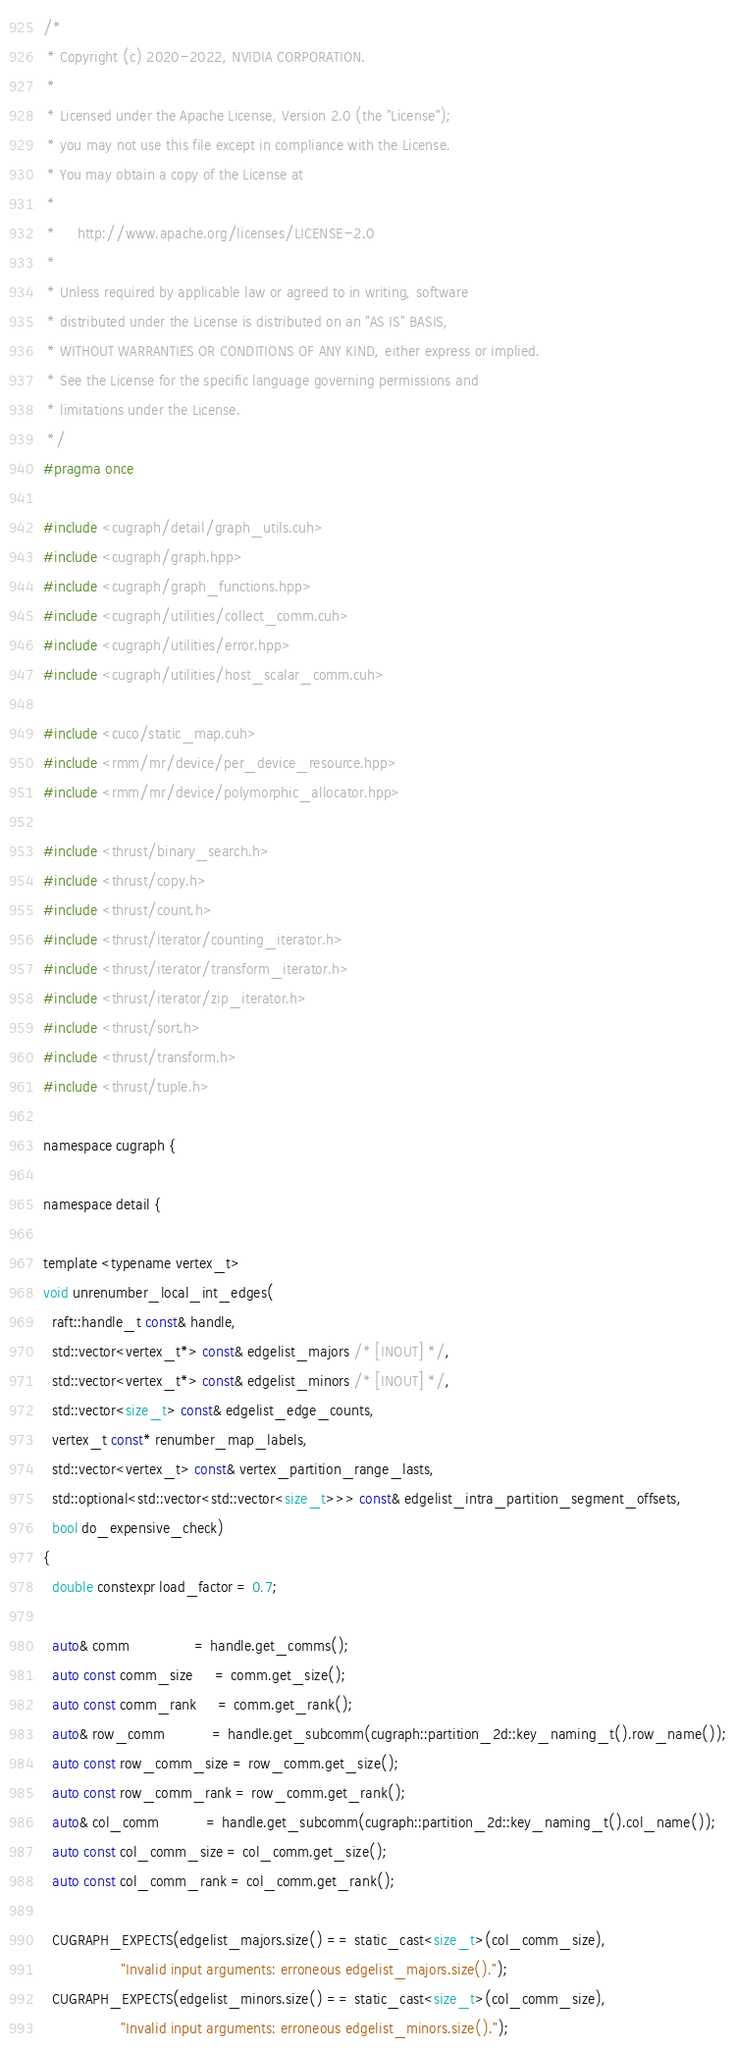<code> <loc_0><loc_0><loc_500><loc_500><_Cuda_>/*
 * Copyright (c) 2020-2022, NVIDIA CORPORATION.
 *
 * Licensed under the Apache License, Version 2.0 (the "License");
 * you may not use this file except in compliance with the License.
 * You may obtain a copy of the License at
 *
 *     http://www.apache.org/licenses/LICENSE-2.0
 *
 * Unless required by applicable law or agreed to in writing, software
 * distributed under the License is distributed on an "AS IS" BASIS,
 * WITHOUT WARRANTIES OR CONDITIONS OF ANY KIND, either express or implied.
 * See the License for the specific language governing permissions and
 * limitations under the License.
 */
#pragma once

#include <cugraph/detail/graph_utils.cuh>
#include <cugraph/graph.hpp>
#include <cugraph/graph_functions.hpp>
#include <cugraph/utilities/collect_comm.cuh>
#include <cugraph/utilities/error.hpp>
#include <cugraph/utilities/host_scalar_comm.cuh>

#include <cuco/static_map.cuh>
#include <rmm/mr/device/per_device_resource.hpp>
#include <rmm/mr/device/polymorphic_allocator.hpp>

#include <thrust/binary_search.h>
#include <thrust/copy.h>
#include <thrust/count.h>
#include <thrust/iterator/counting_iterator.h>
#include <thrust/iterator/transform_iterator.h>
#include <thrust/iterator/zip_iterator.h>
#include <thrust/sort.h>
#include <thrust/transform.h>
#include <thrust/tuple.h>

namespace cugraph {

namespace detail {

template <typename vertex_t>
void unrenumber_local_int_edges(
  raft::handle_t const& handle,
  std::vector<vertex_t*> const& edgelist_majors /* [INOUT] */,
  std::vector<vertex_t*> const& edgelist_minors /* [INOUT] */,
  std::vector<size_t> const& edgelist_edge_counts,
  vertex_t const* renumber_map_labels,
  std::vector<vertex_t> const& vertex_partition_range_lasts,
  std::optional<std::vector<std::vector<size_t>>> const& edgelist_intra_partition_segment_offsets,
  bool do_expensive_check)
{
  double constexpr load_factor = 0.7;

  auto& comm               = handle.get_comms();
  auto const comm_size     = comm.get_size();
  auto const comm_rank     = comm.get_rank();
  auto& row_comm           = handle.get_subcomm(cugraph::partition_2d::key_naming_t().row_name());
  auto const row_comm_size = row_comm.get_size();
  auto const row_comm_rank = row_comm.get_rank();
  auto& col_comm           = handle.get_subcomm(cugraph::partition_2d::key_naming_t().col_name());
  auto const col_comm_size = col_comm.get_size();
  auto const col_comm_rank = col_comm.get_rank();

  CUGRAPH_EXPECTS(edgelist_majors.size() == static_cast<size_t>(col_comm_size),
                  "Invalid input arguments: erroneous edgelist_majors.size().");
  CUGRAPH_EXPECTS(edgelist_minors.size() == static_cast<size_t>(col_comm_size),
                  "Invalid input arguments: erroneous edgelist_minors.size().");</code> 